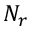Convert formula to latex. <formula><loc_0><loc_0><loc_500><loc_500>N _ { r }</formula> 